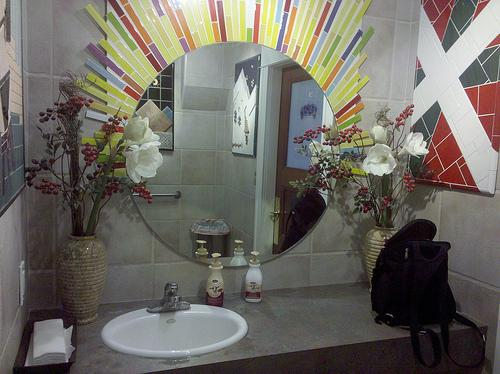Describe the sink, faucet, and any fixtures in the image. The white sink sits below the round mirror, with a silver faucet extending above it and a brass handle visible on the door in the reflection. Mention the color and design of the wall tiles in the image. The wall tiles are red, white, and gray, with a decorative pattern resembling a colorful decoration above the round mirror. Provide a brief summary of the image contents. A bathroom scene with a round mirror, white sink, soap and paper towels on a gray counter, an open black bag, white flowers in a vase, and colorful wall tiles. Explain the hand washing supplies provided in the image. Two bottles of hand washing soap, one cream-colored and one white, are on the gray counter, along with a stack of white paper towels in a holder. Describe the position and appearance of the mirror in the image. The round mirror is mounted on the wall above the white sink, with stickers decorating its surface and a photo frame reflected in it. Describe the appearance of the bathroom counter in the image. The bathroom counter is gray and holds an open black bag, white paper towels, hand washing soap in two bottles, a vase with white flowers, and a silver faucet. Detail the flower arrangement present in the image. A vase with white flowers and green stems sits on the bathroom counter, with a large white flower on a stem nearby. Mention three main objects seen in the image and their positions. A round mirror on the wall, a white sink below the mirror, and an open black bag on the gray bathroom counter. Talk about the open black bag on the bathroom counter. A black bag with visible straps is open atop the gray bathroom counter, with various items inside. Comment on the decorative elements in the image. The bathroom has a round mirror with stickers, colorful wall tiles above the mirror, and white flowers in a vase on the counter. 